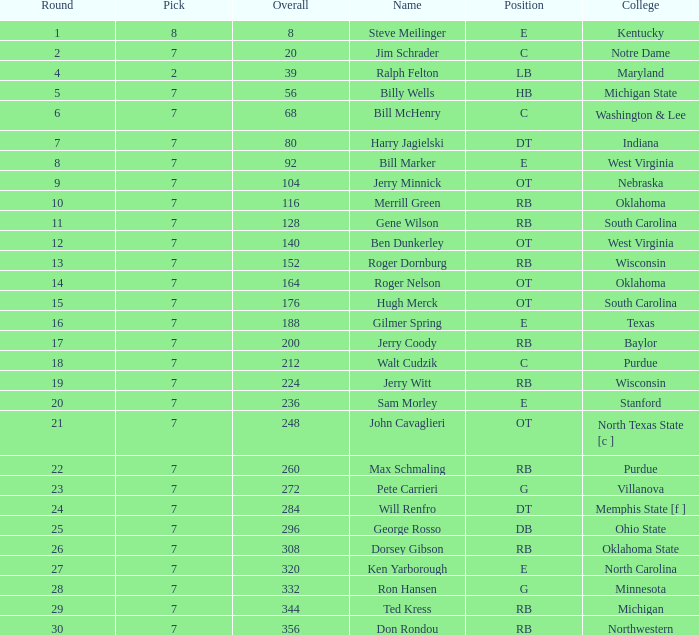In which round was ron hansen drafted, where the overall pick exceeded 332? 0.0. 